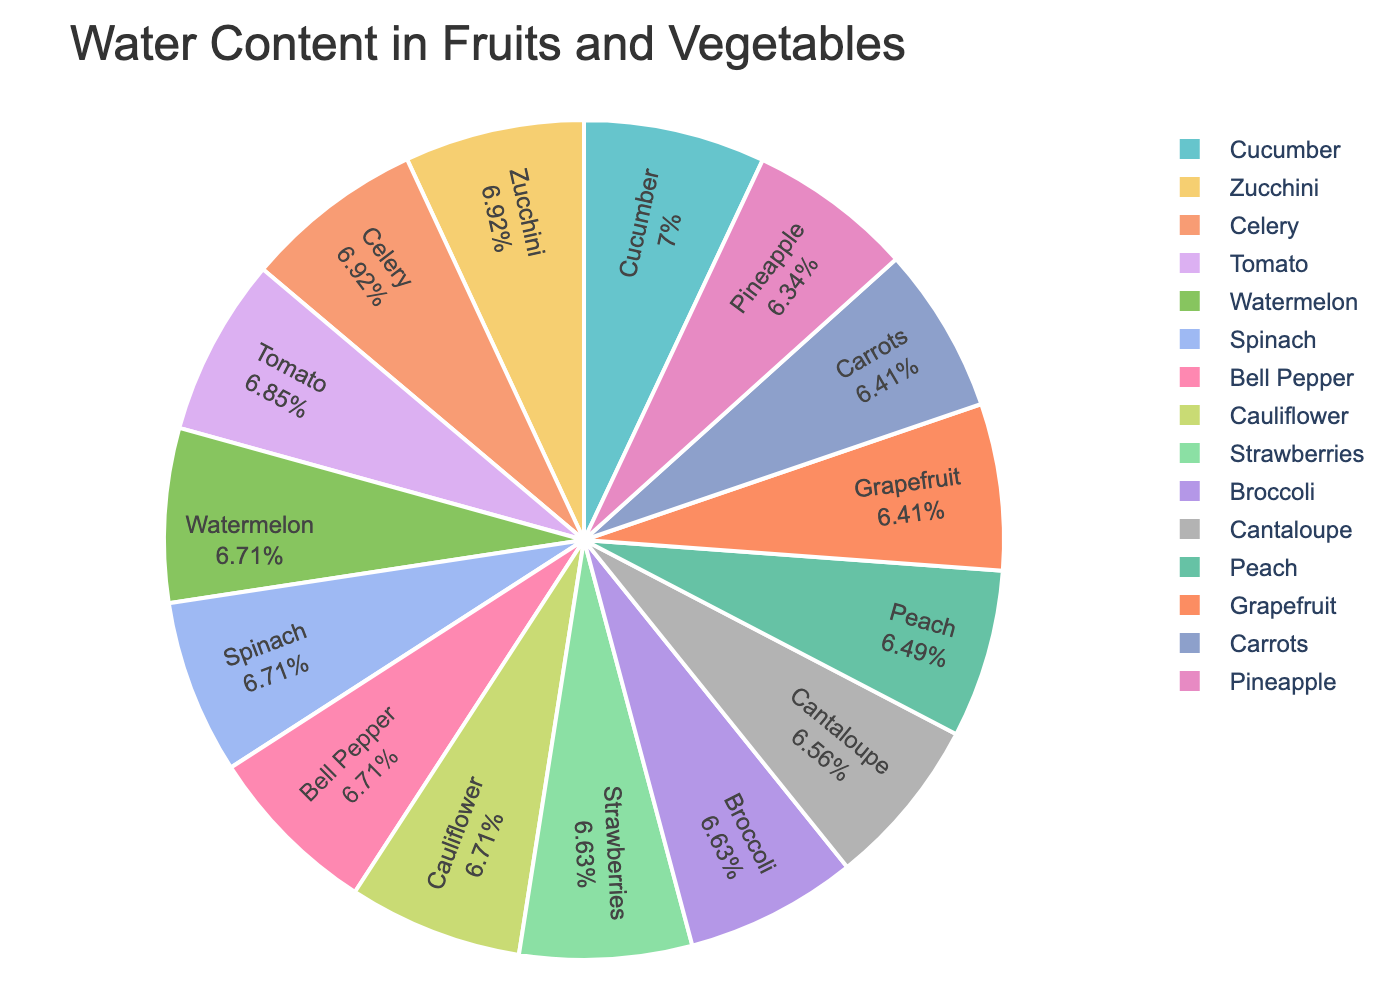Which fruit or vegetable has the highest water content? By examining the labels inside each pie segment, we can see that the cucumber has the highest water content, as its label shows 96%.
Answer: Cucumber Which fruit or vegetable has the lowest water content? By looking at all the percentages displayed within the pie segments, we determine that pineapple has the lowest water content at 87%.
Answer: Pineapple Are there more fruits or vegetables in the pie chart with a water content greater than or equal to 90%? By counting, we see there are 7 fruits (watermelon, strawberries, cantaloupe, grapefruit, peach, pineapple, broccoli) and 7 vegetables (cucumber, zucchini, celery, tomato, spinach, bell pepper, cauliflower) on the chart. Out of these, 8 have a water content above 90% (cucumber, watermelon, strawberries, zucchini, celery, tomato, spinach, bell pepper). So, fruits and vegetables are equally distributed.
Answer: They are equal Which has higher water content, bell pepper or carrots? By comparing the pie segments for bell pepper and carrots, we see that bell pepper has a water content of 92% while carrots have 88%.
Answer: Bell pepper What is the average water content of all the fruits in the chart? To find the average: (92 + 91 + 90 + 88 + 89 + 87)/6 = 88.83%. So, the average water content of the fruits is approximately 88.83%.
Answer: 88.83% How much more water content does cucumber have compared to grapefruit? Cucumber has 96%, and grapefruit has 88%. The difference is 96% - 88% = 8%.
Answer: 8% Which item has a water content closest to 90%? By checking the values close to 90% in the chart, we see cantaloupe has a water content of 90%.
Answer: Cantaloupe If you were to combine the water content of tomato and celery, what would the combined percentage be? Tomato has 94% and celery has 95%. Combined, their water content is (94 + 95) = 189%.
Answer: 189% Which vegetable has the same water content as strawberries? Both strawberries and cauliflower have a water content of 92%.
Answer: Cauliflower 